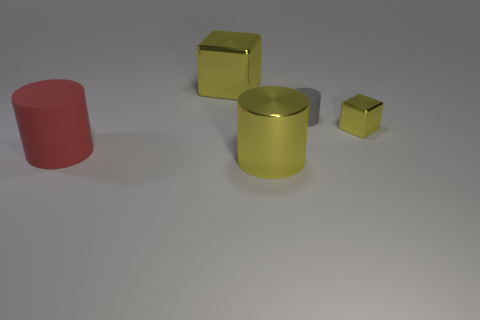The other gray rubber object that is the same shape as the large rubber thing is what size?
Ensure brevity in your answer.  Small. There is a thing that is right of the matte thing that is right of the big block; how many yellow objects are behind it?
Your response must be concise. 1. Are there an equal number of gray matte cylinders in front of the tiny shiny object and tiny gray things?
Provide a short and direct response. No. How many blocks are either red objects or small yellow objects?
Offer a very short reply. 1. Does the large metallic block have the same color as the small metallic thing?
Offer a terse response. Yes. Is the number of tiny gray objects that are on the left side of the red matte cylinder the same as the number of yellow metal objects right of the big block?
Your answer should be compact. No. The metallic cylinder has what color?
Give a very brief answer. Yellow. What number of things are metal cubes that are to the right of the small matte cylinder or tiny matte things?
Ensure brevity in your answer.  2. There is a cylinder behind the big red object; is it the same size as the yellow block that is right of the gray rubber cylinder?
Provide a short and direct response. Yes. What number of things are either matte objects that are in front of the small yellow block or yellow things in front of the gray matte object?
Your response must be concise. 3. 